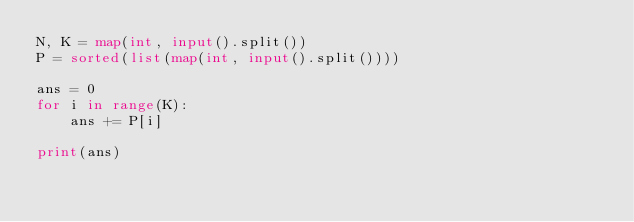<code> <loc_0><loc_0><loc_500><loc_500><_Python_>N, K = map(int, input().split())
P = sorted(list(map(int, input().split())))

ans = 0
for i in range(K):
    ans += P[i]

print(ans)
</code> 